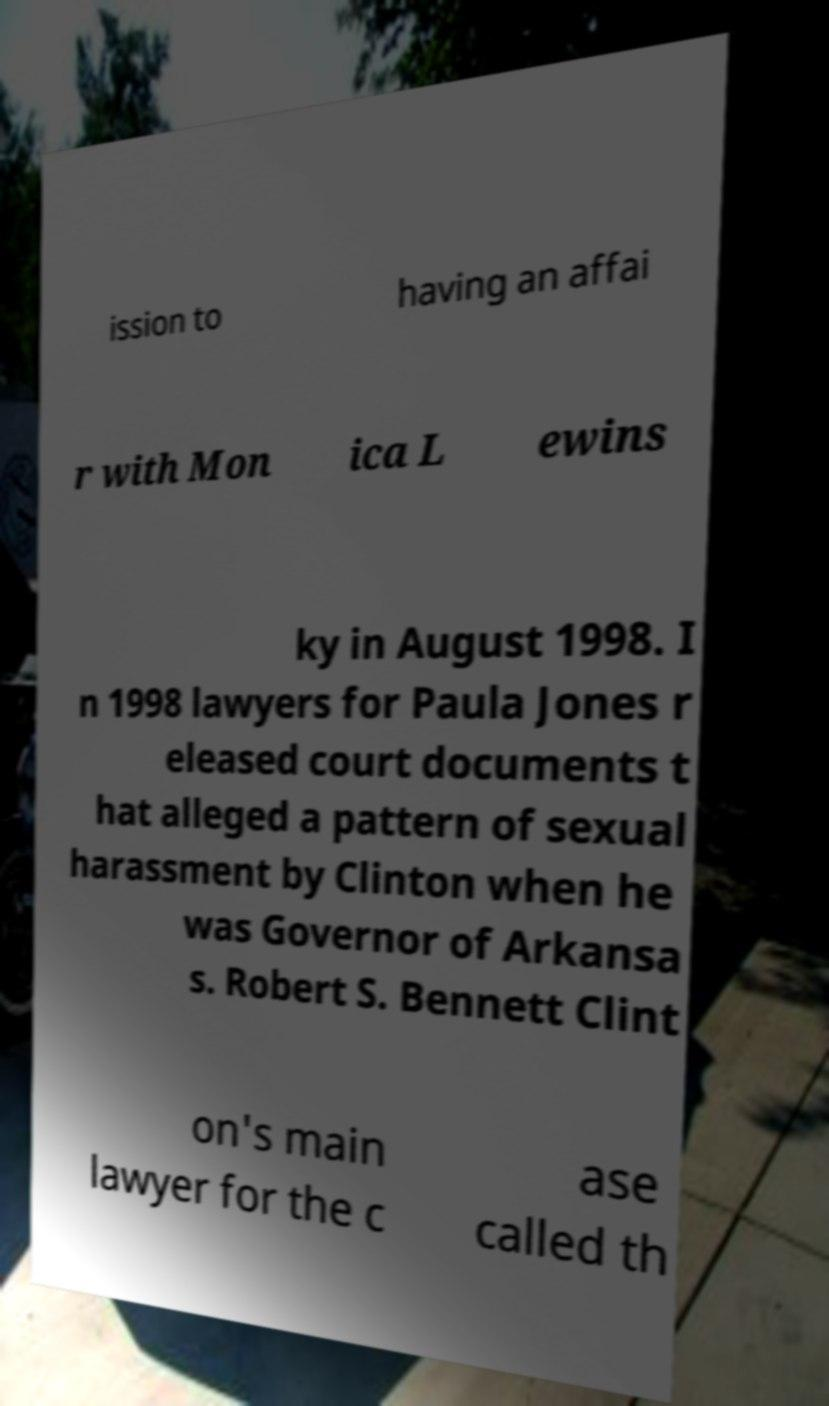What messages or text are displayed in this image? I need them in a readable, typed format. ission to having an affai r with Mon ica L ewins ky in August 1998. I n 1998 lawyers for Paula Jones r eleased court documents t hat alleged a pattern of sexual harassment by Clinton when he was Governor of Arkansa s. Robert S. Bennett Clint on's main lawyer for the c ase called th 